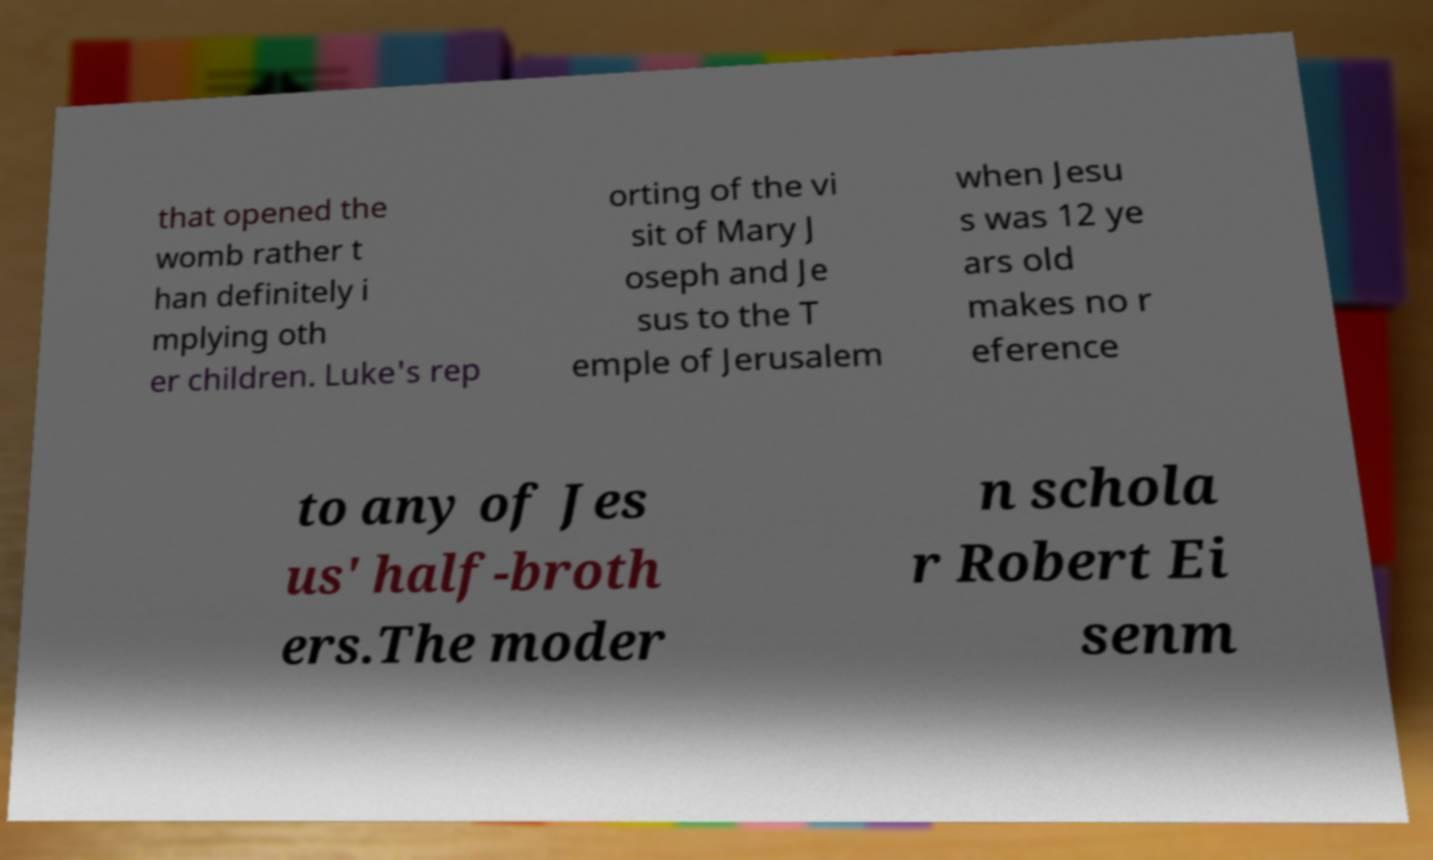For documentation purposes, I need the text within this image transcribed. Could you provide that? that opened the womb rather t han definitely i mplying oth er children. Luke's rep orting of the vi sit of Mary J oseph and Je sus to the T emple of Jerusalem when Jesu s was 12 ye ars old makes no r eference to any of Jes us' half-broth ers.The moder n schola r Robert Ei senm 